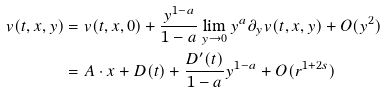Convert formula to latex. <formula><loc_0><loc_0><loc_500><loc_500>v ( t , x , y ) & = v ( t , x , 0 ) + \frac { y ^ { 1 - a } } { 1 - a } \lim _ { y \to 0 } y ^ { a } \partial _ { y } v ( t , x , y ) + O ( y ^ { 2 } ) \\ & = A \cdot x + D ( t ) + \frac { D ^ { \prime } ( t ) } { 1 - a } y ^ { 1 - a } + O ( r ^ { 1 + 2 s } )</formula> 